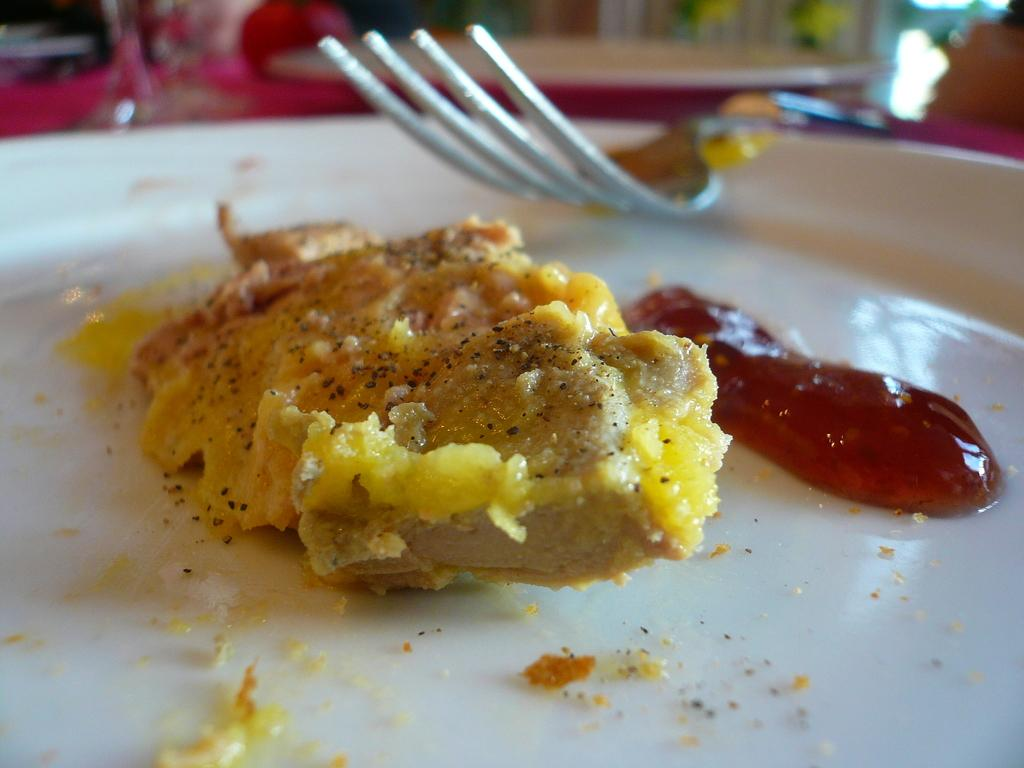What is present on the plate in the image? There are food items on the plate in the image. What utensil can be seen in the image? There is a spoon in the image. Can you describe the food items on the plate? Unfortunately, the specific food items cannot be determined from the provided facts. What type of soup can be seen in the image? There is no soup present in the image. 